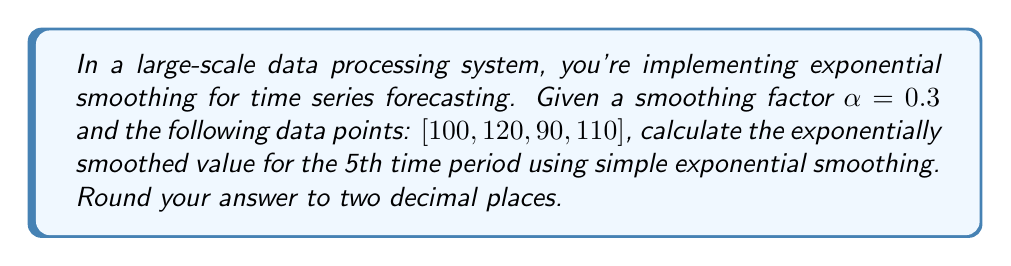Can you solve this math problem? Let's approach this step-by-step using the simple exponential smoothing formula:

1) The formula for simple exponential smoothing is:
   $$S_t = \alpha Y_t + (1-\alpha)S_{t-1}$$
   where $S_t$ is the smoothed value, $Y_t$ is the observed value, and $\alpha$ is the smoothing factor.

2) We're given $\alpha = 0.3$ and the data points $[100, 120, 90, 110]$.

3) Let's calculate the smoothed values:

   For $t=1$: $S_1 = Y_1 = 100$ (initialization)
   
   For $t=2$: $S_2 = 0.3(120) + 0.7(100) = 36 + 70 = 106$
   
   For $t=3$: $S_3 = 0.3(90) + 0.7(106) = 27 + 74.2 = 101.2$
   
   For $t=4$: $S_4 = 0.3(110) + 0.7(101.2) = 33 + 70.84 = 103.84$

4) For the 5th period, we don't have an observed value, so we use the last smoothed value as our forecast:

   $S_5 = S_4 = 103.84$

5) Rounding to two decimal places: 103.84
Answer: 103.84 